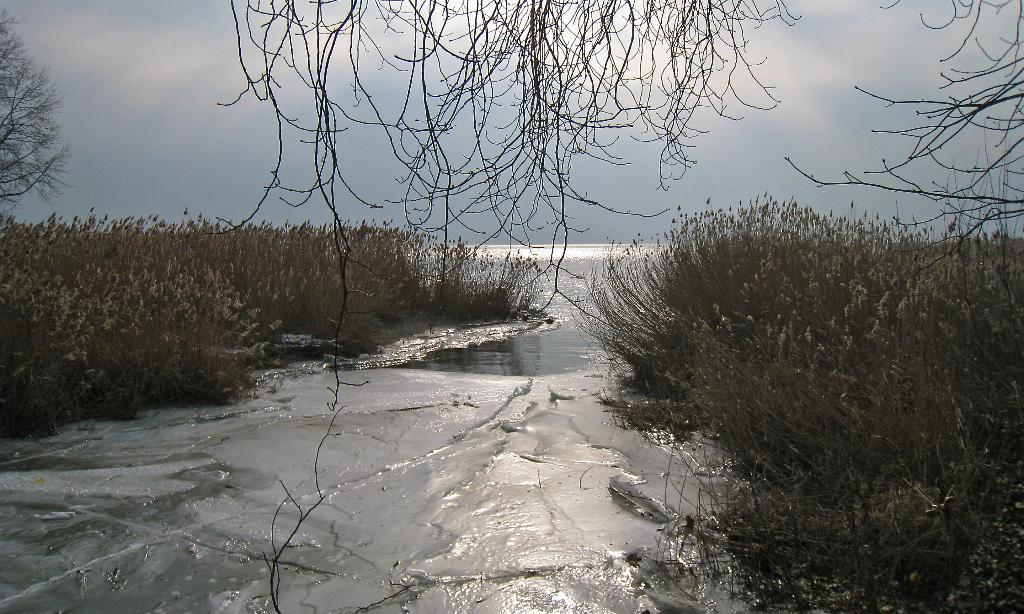What is the primary element visible in the image? Water is visible in the image. What type of vegetation can be seen in the image? There are plants and trees in the image. What is visible in the background of the image? The sky is visible in the background of the image. What type of magic is being performed with the butter in the image? There is no butter or magic present in the image. 